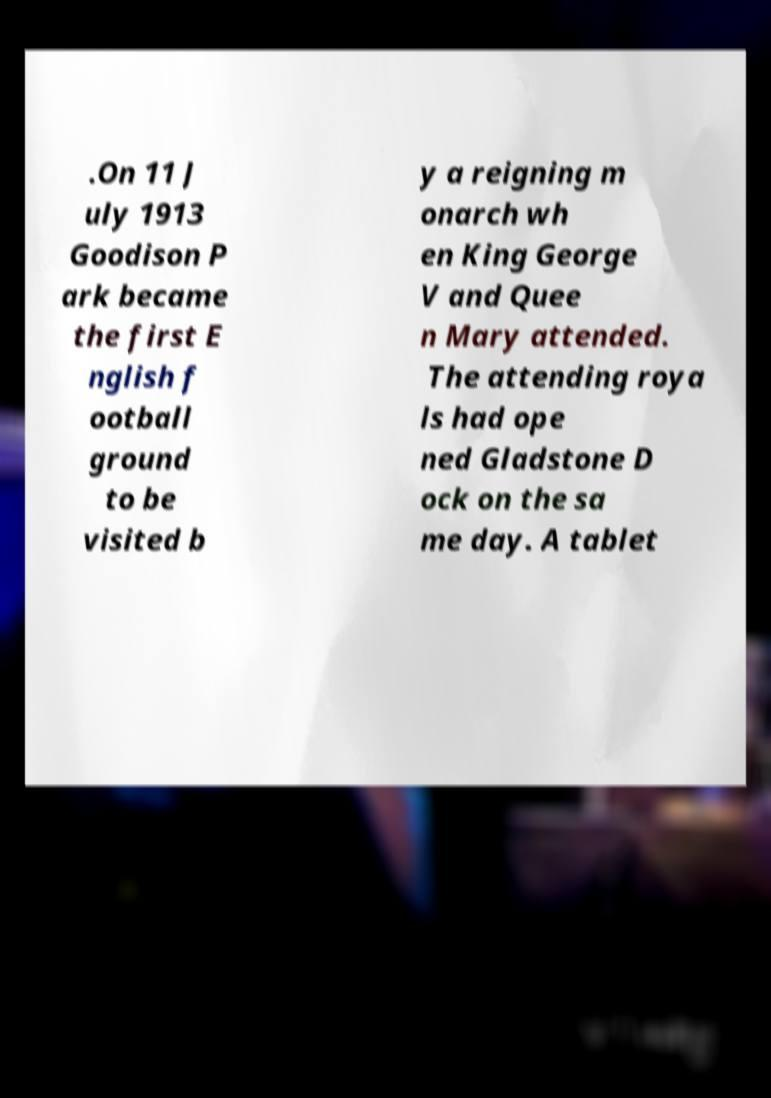For documentation purposes, I need the text within this image transcribed. Could you provide that? .On 11 J uly 1913 Goodison P ark became the first E nglish f ootball ground to be visited b y a reigning m onarch wh en King George V and Quee n Mary attended. The attending roya ls had ope ned Gladstone D ock on the sa me day. A tablet 